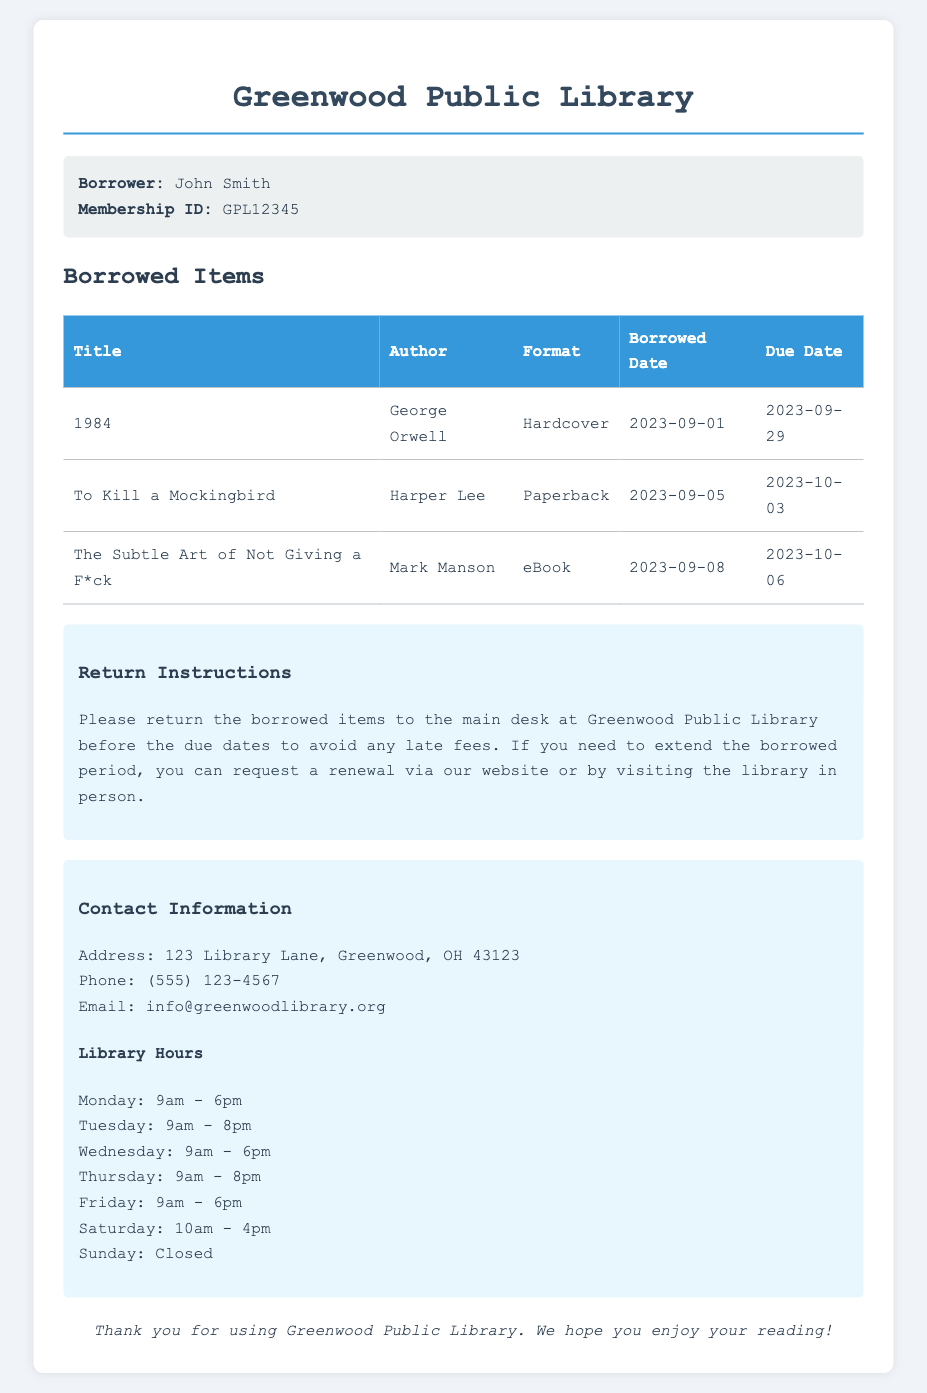What is the name of the borrower? The borrower's name is stated in the borrower info section of the document.
Answer: John Smith What is the membership ID of the borrower? The membership ID is provided in the borrower info section, which uniquely identifies the borrower.
Answer: GPL12345 What is the due date for the book '1984'? The due date for '1984' is specified in the table of borrowed items, indicating when the book needs to be returned.
Answer: 2023-09-29 How many days are left to return 'To Kill a Mockingbird'? To find the days left, calculate from the current date to the due date, which is mentioned in the borrowed items.
Answer: 12 days What is the format of 'The Subtle Art of Not Giving a F*ck'? The format is described in the borrowed items table, specifying how the book is available.
Answer: eBook What should be done to avoid late fees? The document contains instructions on how to avoid late fees related to borrowed items.
Answer: Return borrowed items before due dates Where is the library located? The address of the library is stated in the contact information section, providing information on where to find it.
Answer: 123 Library Lane, Greenwood, OH 43123 What time does the library open on Tuesdays? The opening times are listed in the library hours section, indicating when services begin for each day.
Answer: 9am How can a borrower extend the borrowed period? The document specifies the methods available for requesting an extension on borrowed items.
Answer: Request a renewal via website or in person 